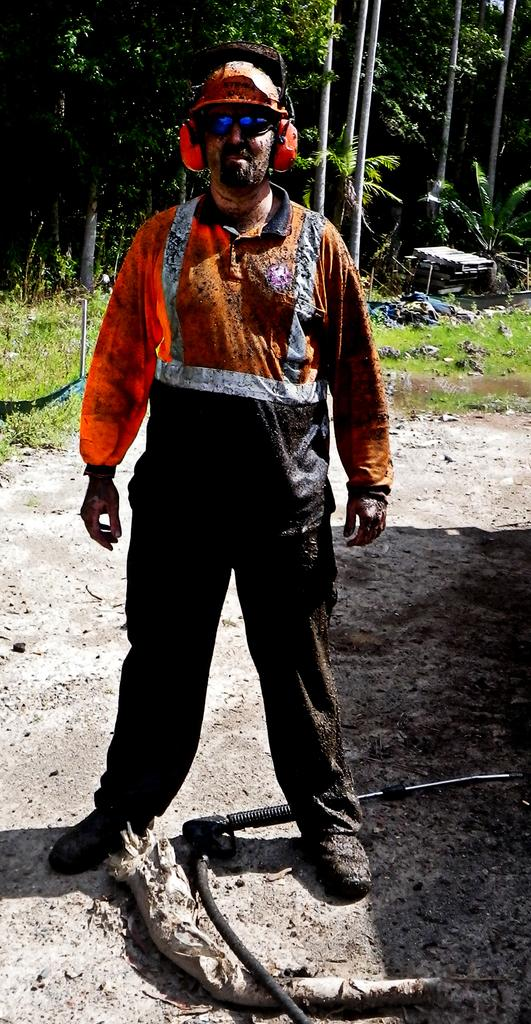What is the main subject of the image? There is a man standing in the image. What is the man standing on? The man is standing on land. What can be seen in the background of the image? There are trees in the background of the image. What type of lace is the actor wearing in the image? There is no actor or lace present in the image; it features a man standing on land with trees in the background. 